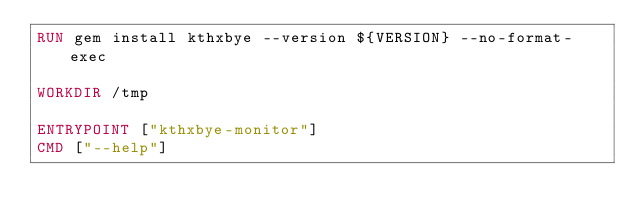<code> <loc_0><loc_0><loc_500><loc_500><_Dockerfile_>RUN gem install kthxbye --version ${VERSION} --no-format-exec

WORKDIR /tmp

ENTRYPOINT ["kthxbye-monitor"]
CMD ["--help"]
</code> 